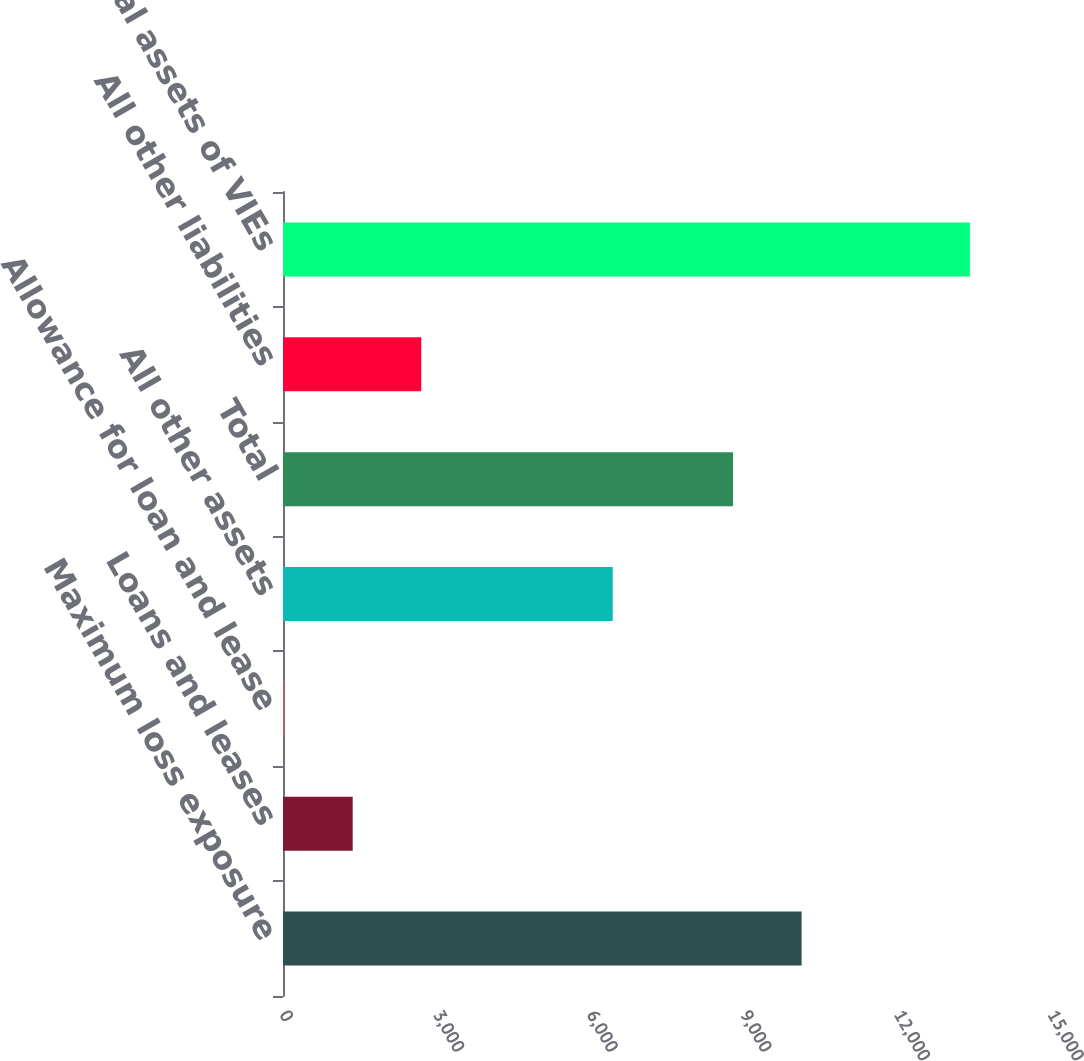Convert chart to OTSL. <chart><loc_0><loc_0><loc_500><loc_500><bar_chart><fcel>Maximum loss exposure<fcel>Loans and leases<fcel>Allowance for loan and lease<fcel>All other assets<fcel>Total<fcel>All other liabilities<fcel>Total assets of VIEs<nl><fcel>10129.4<fcel>1361.4<fcel>22<fcel>6440<fcel>8790<fcel>2700.8<fcel>13416<nl></chart> 